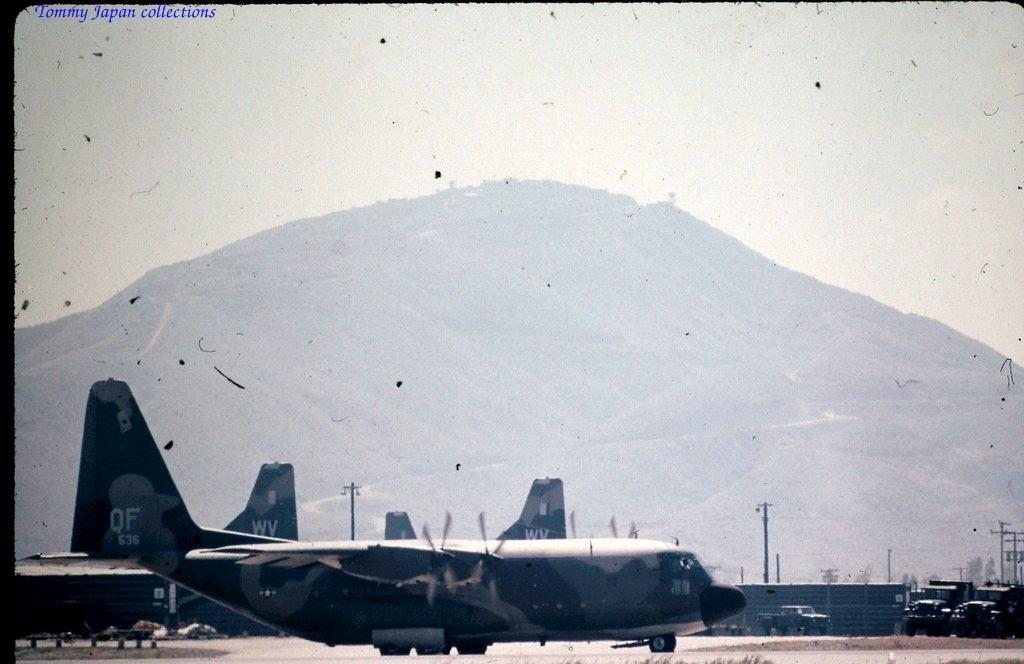What is the main subject of the image? The main subject of the image is an airplane. What else can be seen on the ground in the image? There are vehicles on the road in the image. What can be seen in the distance in the image? There are buildings, electric poles, trees, a mountain, and the sky visible in the background of the image. How many pigs are visible in the image? There are no pigs present in the image. What type of addition problem can be solved using the numbers on the airplane? There are no numbers visible on the airplane in the image, so it is not possible to solve an addition problem based on the image. 